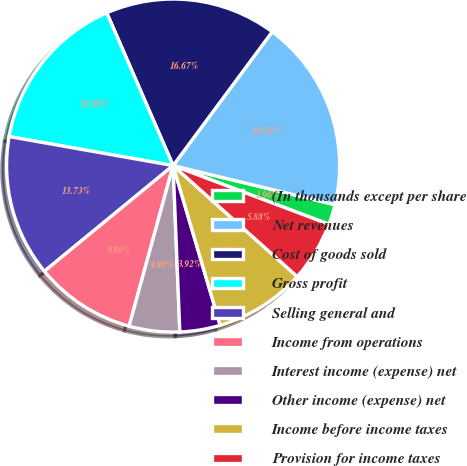Convert chart. <chart><loc_0><loc_0><loc_500><loc_500><pie_chart><fcel>(In thousands except per share<fcel>Net revenues<fcel>Cost of goods sold<fcel>Gross profit<fcel>Selling general and<fcel>Income from operations<fcel>Interest income (expense) net<fcel>Other income (expense) net<fcel>Income before income taxes<fcel>Provision for income taxes<nl><fcel>1.96%<fcel>18.63%<fcel>16.67%<fcel>15.69%<fcel>13.73%<fcel>9.8%<fcel>4.9%<fcel>3.92%<fcel>8.82%<fcel>5.88%<nl></chart> 